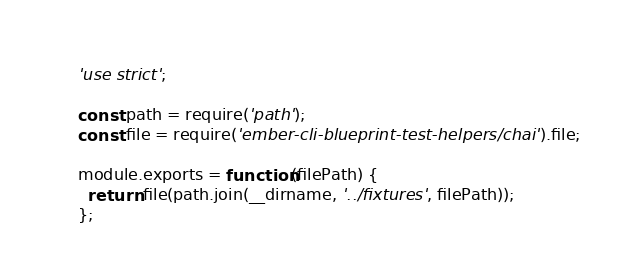Convert code to text. <code><loc_0><loc_0><loc_500><loc_500><_JavaScript_>'use strict';

const path = require('path');
const file = require('ember-cli-blueprint-test-helpers/chai').file;

module.exports = function(filePath) {
  return file(path.join(__dirname, '../fixtures', filePath));
};
</code> 